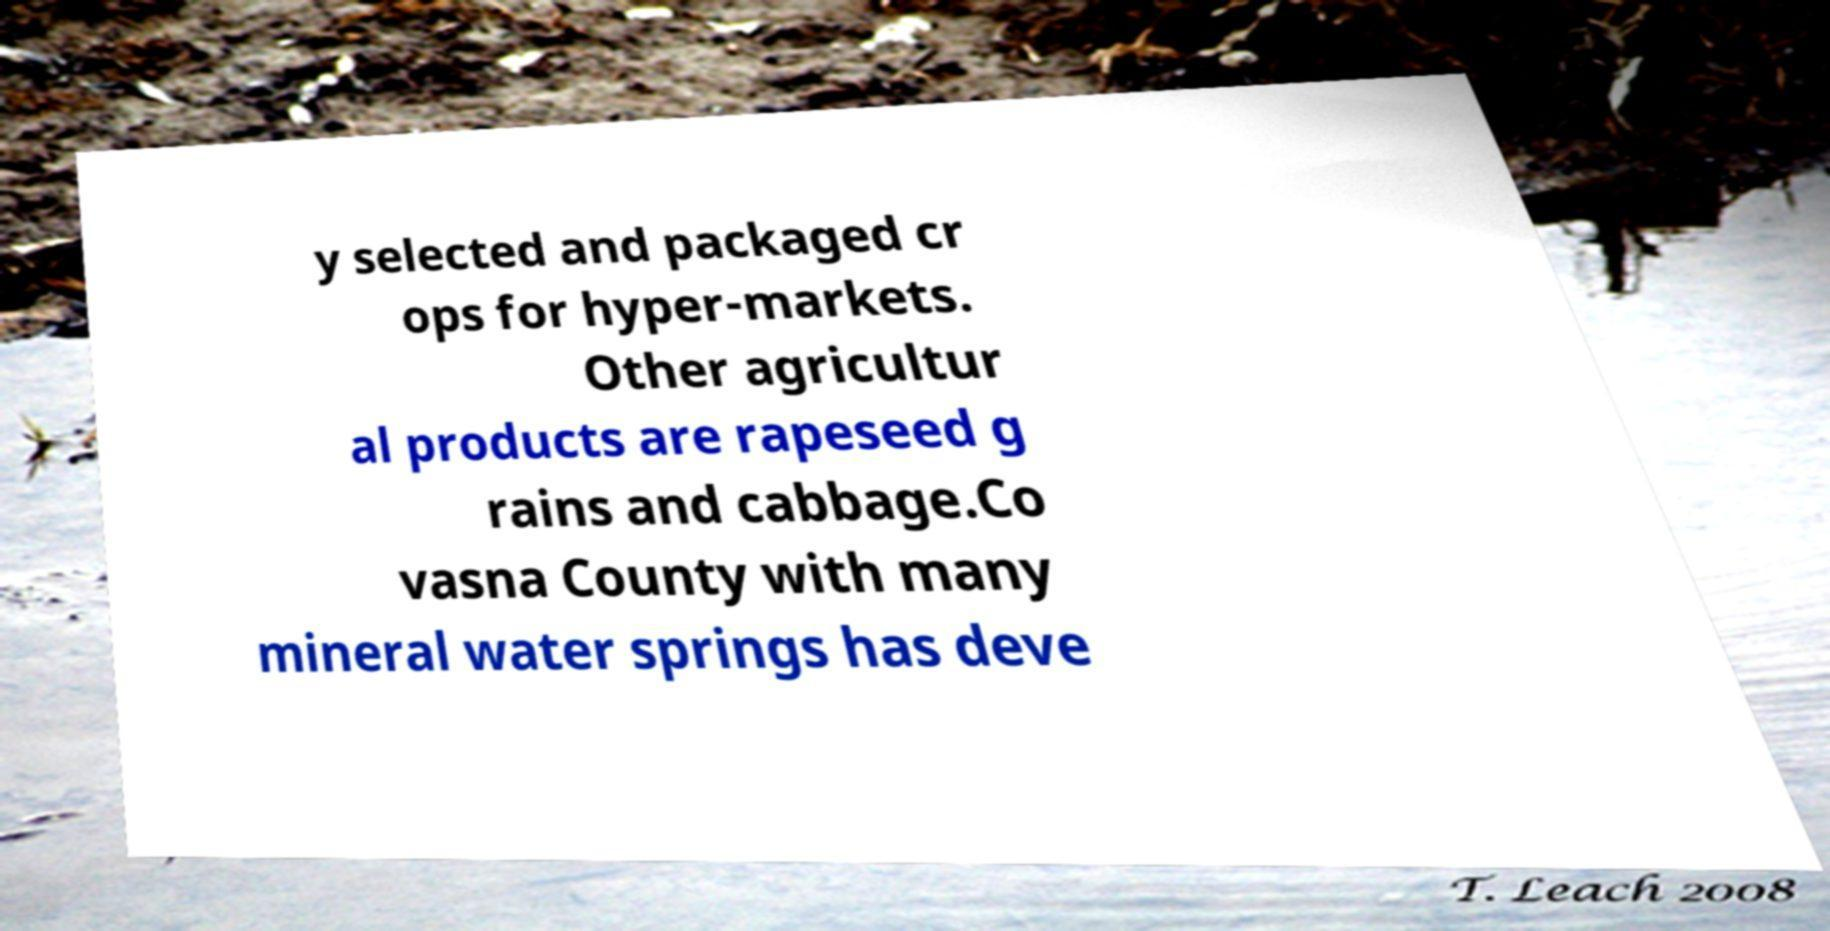Please identify and transcribe the text found in this image. y selected and packaged cr ops for hyper-markets. Other agricultur al products are rapeseed g rains and cabbage.Co vasna County with many mineral water springs has deve 